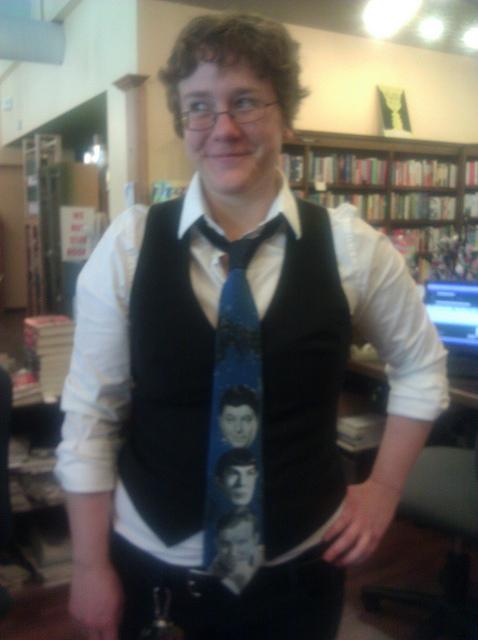What is on his face?
Keep it brief. Glasses. What is on the person's tie?
Answer briefly. Star trek characters. Where was this picture taken?
Give a very brief answer. Library. 